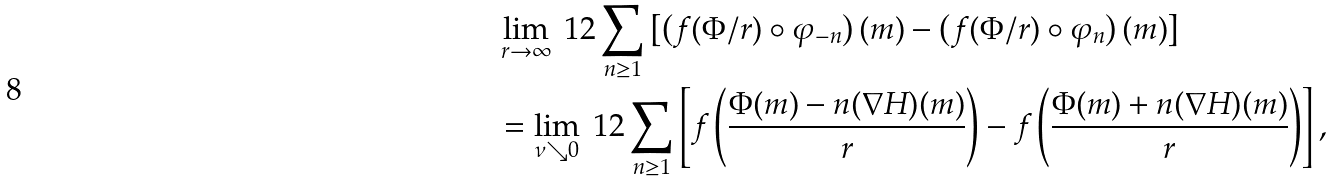<formula> <loc_0><loc_0><loc_500><loc_500>& \lim _ { r \to \infty } \ 1 2 \sum _ { n \geq 1 } \left [ \left ( f ( \Phi / r ) \circ \varphi _ { - n } \right ) ( m ) - \left ( f ( \Phi / r ) \circ \varphi _ { n } \right ) ( m ) \right ] \\ & = \lim _ { \nu \searrow 0 } \ 1 2 \sum _ { n \geq 1 } \left [ f \left ( \frac { \Phi ( m ) - n ( \nabla H ) ( m ) } r \right ) - f \left ( \frac { \Phi ( m ) + n ( \nabla H ) ( m ) } r \right ) \right ] ,</formula> 